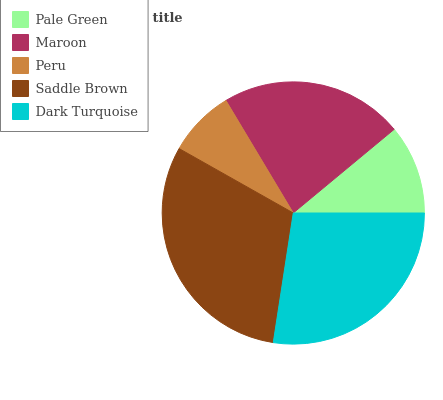Is Peru the minimum?
Answer yes or no. Yes. Is Saddle Brown the maximum?
Answer yes or no. Yes. Is Maroon the minimum?
Answer yes or no. No. Is Maroon the maximum?
Answer yes or no. No. Is Maroon greater than Pale Green?
Answer yes or no. Yes. Is Pale Green less than Maroon?
Answer yes or no. Yes. Is Pale Green greater than Maroon?
Answer yes or no. No. Is Maroon less than Pale Green?
Answer yes or no. No. Is Maroon the high median?
Answer yes or no. Yes. Is Maroon the low median?
Answer yes or no. Yes. Is Saddle Brown the high median?
Answer yes or no. No. Is Saddle Brown the low median?
Answer yes or no. No. 